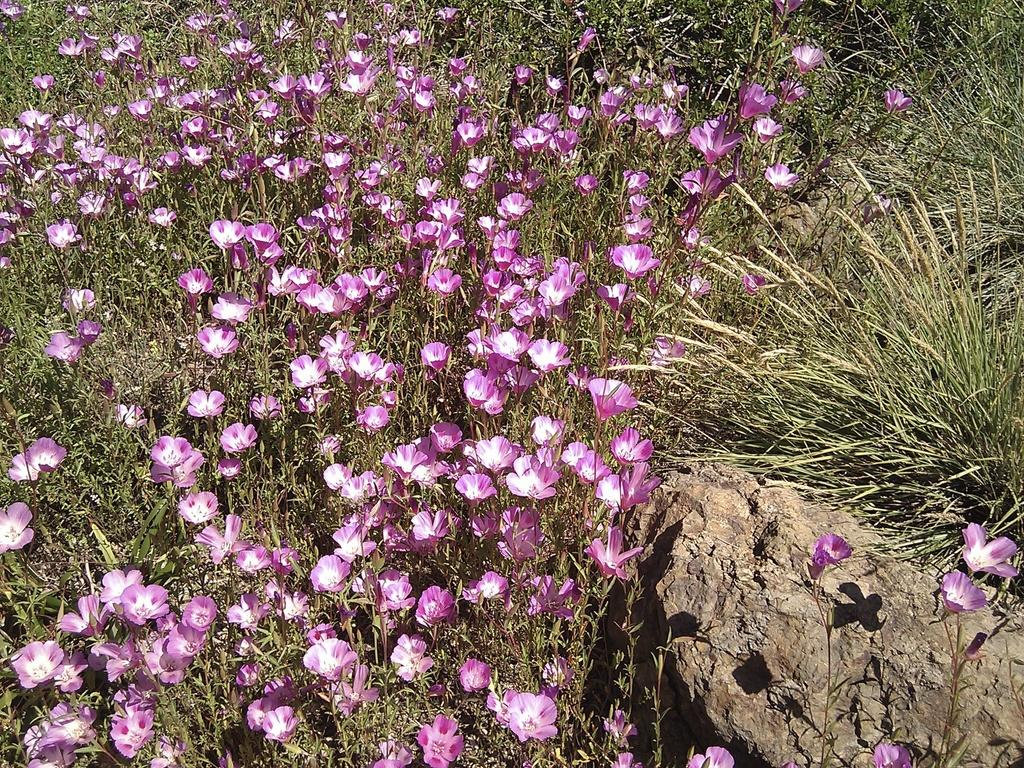What type of plants are visible in the image? There are plants with flowers in the image. What other natural elements can be seen in the image? There is a stone and grass visible in the image. What type of tooth can be seen in the image? There is no tooth present in the image. What type of learning activity is taking place in the image? There is no learning activity present in the image. 